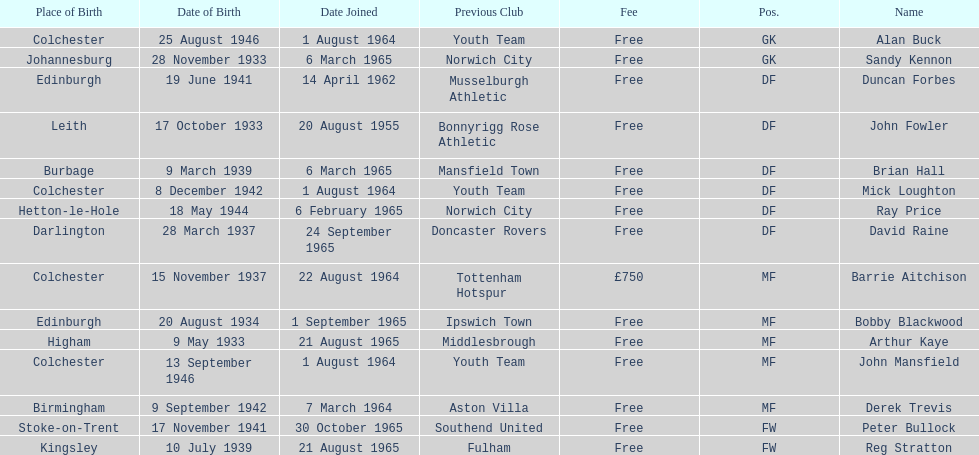What is the date of the lst player that joined? 20 August 1955. 